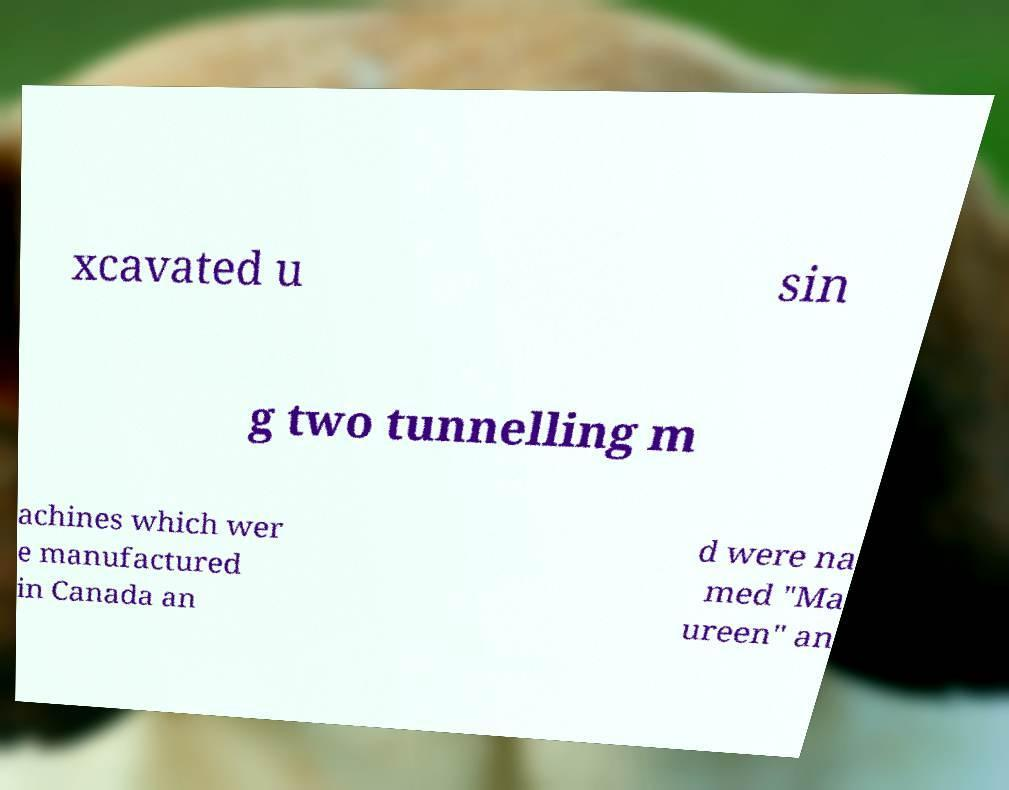There's text embedded in this image that I need extracted. Can you transcribe it verbatim? xcavated u sin g two tunnelling m achines which wer e manufactured in Canada an d were na med "Ma ureen" an 